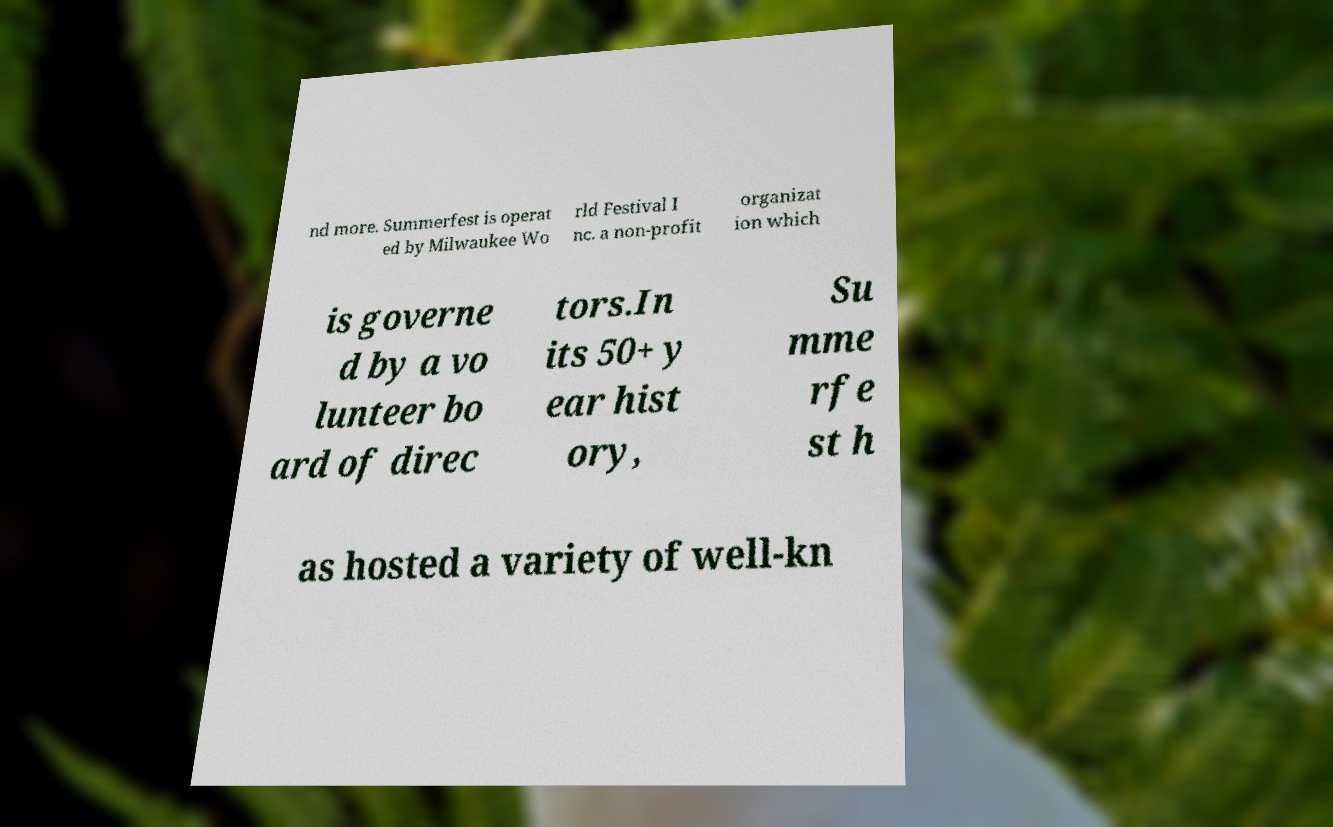Could you extract and type out the text from this image? nd more. Summerfest is operat ed by Milwaukee Wo rld Festival I nc. a non-profit organizat ion which is governe d by a vo lunteer bo ard of direc tors.In its 50+ y ear hist ory, Su mme rfe st h as hosted a variety of well-kn 